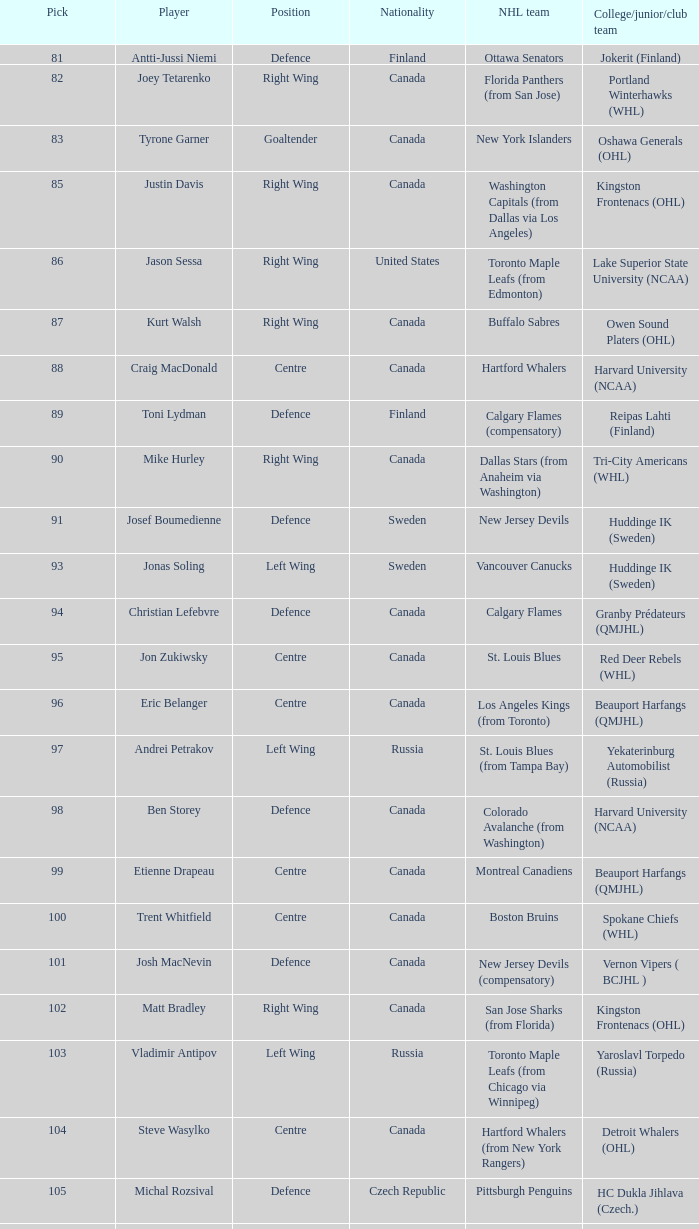How many players came from college team reipas lahti (finland)? 1.0. 